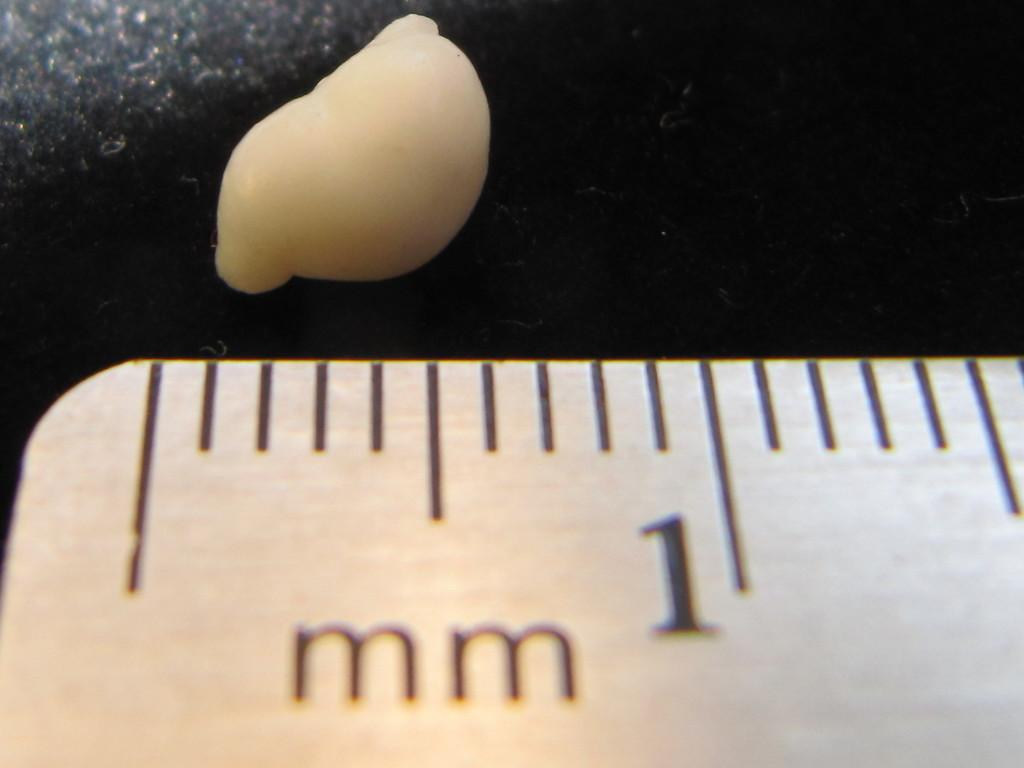Provide a one-sentence caption for the provided image. A ruler has the measurement for 1 mm. 